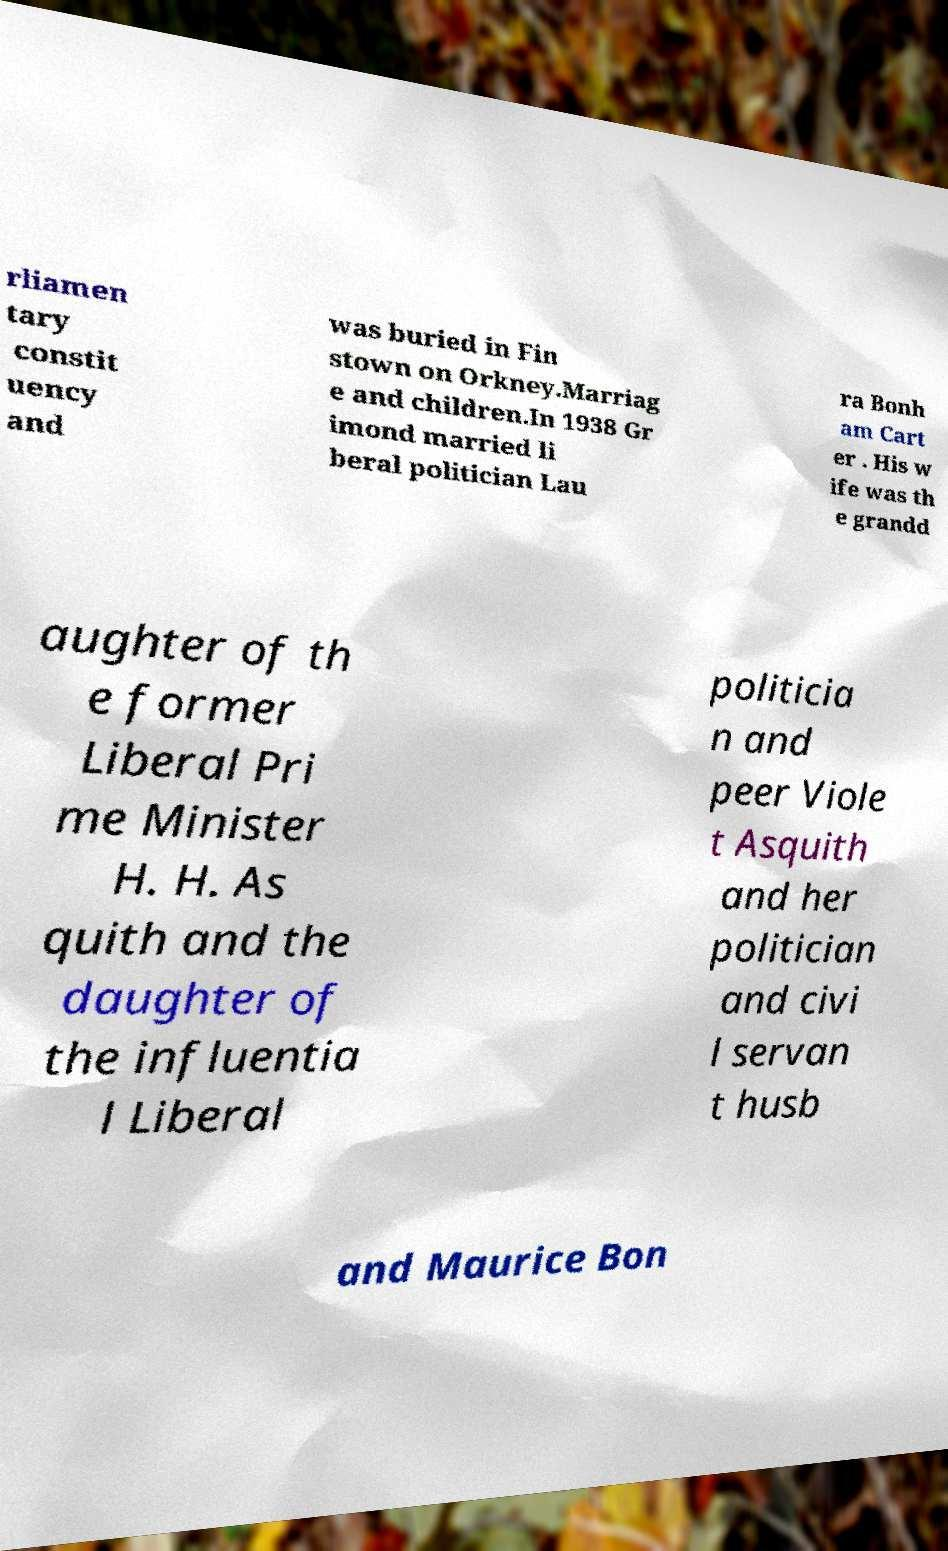I need the written content from this picture converted into text. Can you do that? rliamen tary constit uency and was buried in Fin stown on Orkney.Marriag e and children.In 1938 Gr imond married li beral politician Lau ra Bonh am Cart er . His w ife was th e grandd aughter of th e former Liberal Pri me Minister H. H. As quith and the daughter of the influentia l Liberal politicia n and peer Viole t Asquith and her politician and civi l servan t husb and Maurice Bon 